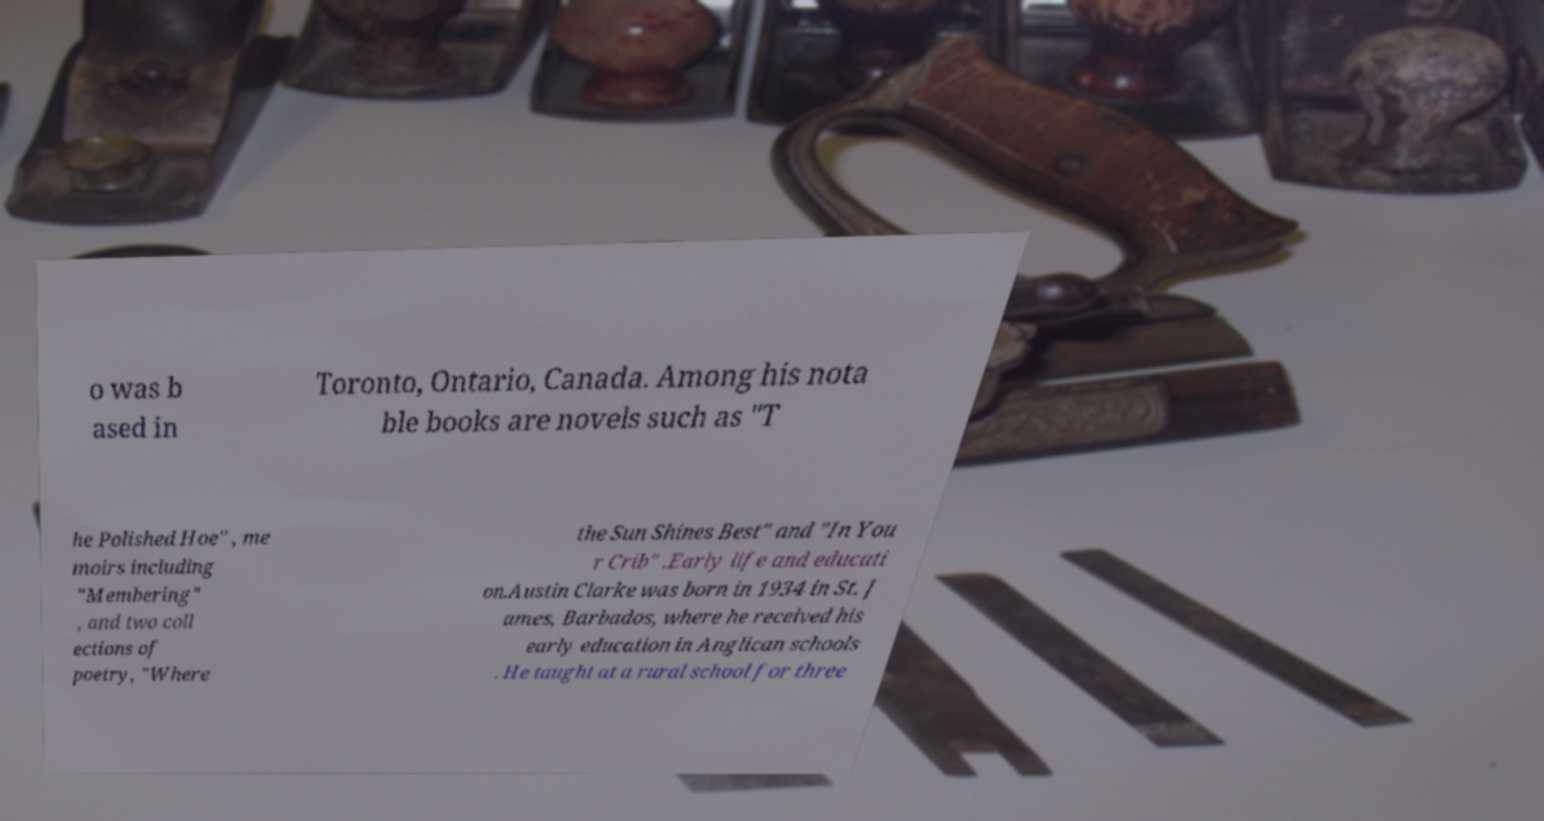Could you extract and type out the text from this image? o was b ased in Toronto, Ontario, Canada. Among his nota ble books are novels such as "T he Polished Hoe" , me moirs including "Membering" , and two coll ections of poetry, "Where the Sun Shines Best" and "In You r Crib" .Early life and educati on.Austin Clarke was born in 1934 in St. J ames, Barbados, where he received his early education in Anglican schools . He taught at a rural school for three 